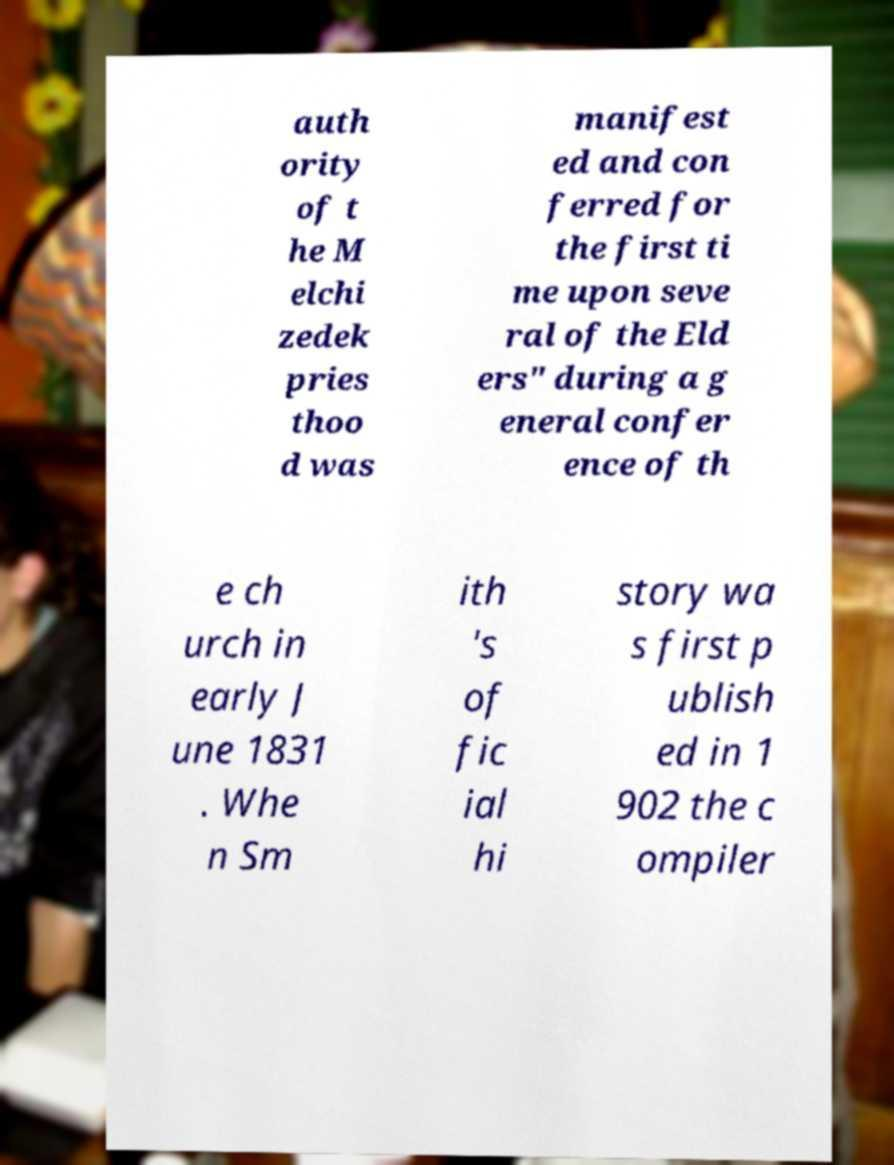Could you assist in decoding the text presented in this image and type it out clearly? auth ority of t he M elchi zedek pries thoo d was manifest ed and con ferred for the first ti me upon seve ral of the Eld ers" during a g eneral confer ence of th e ch urch in early J une 1831 . Whe n Sm ith 's of fic ial hi story wa s first p ublish ed in 1 902 the c ompiler 